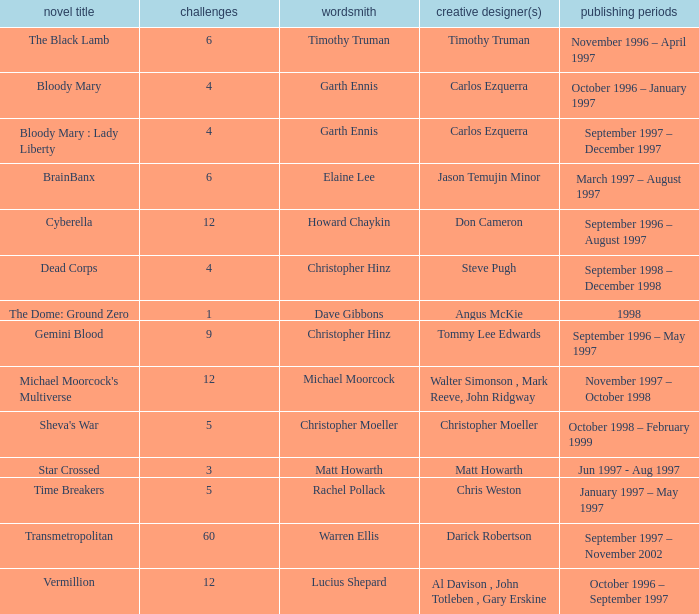What artist has a book called cyberella Don Cameron. 